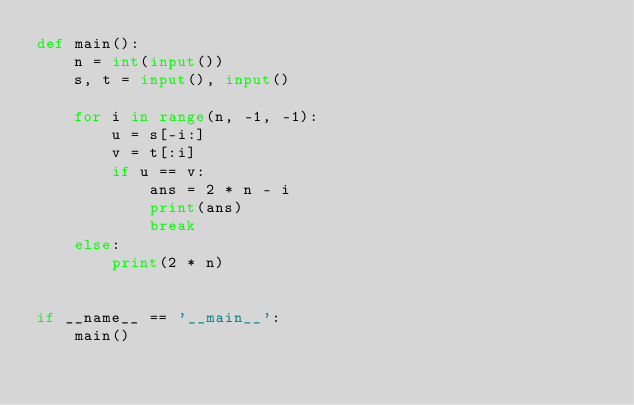Convert code to text. <code><loc_0><loc_0><loc_500><loc_500><_Python_>def main():
    n = int(input())
    s, t = input(), input()

    for i in range(n, -1, -1):
        u = s[-i:]
        v = t[:i]
        if u == v:
            ans = 2 * n - i
            print(ans)
            break
    else:
        print(2 * n)


if __name__ == '__main__':
    main()
</code> 